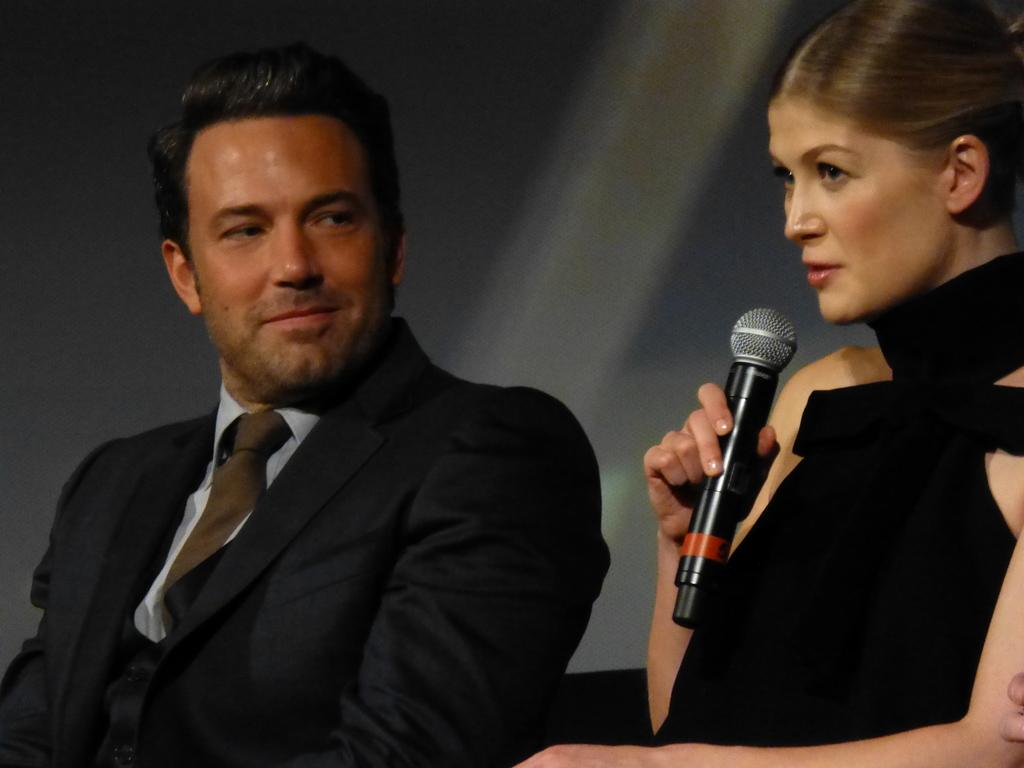What is the woman in the image holding? The woman is holding a mic in her hand. What is the woman doing with the mic? The woman is talking while holding the mic. Can you describe the man in the image? The man is wearing a blazer and a tie. How is the man reacting to the woman in the image? The man is looking at the woman and smiling. What fictional discovery did the woman make in the image? There is no mention of a fictional discovery in the image; the woman is simply holding a mic and talking. 